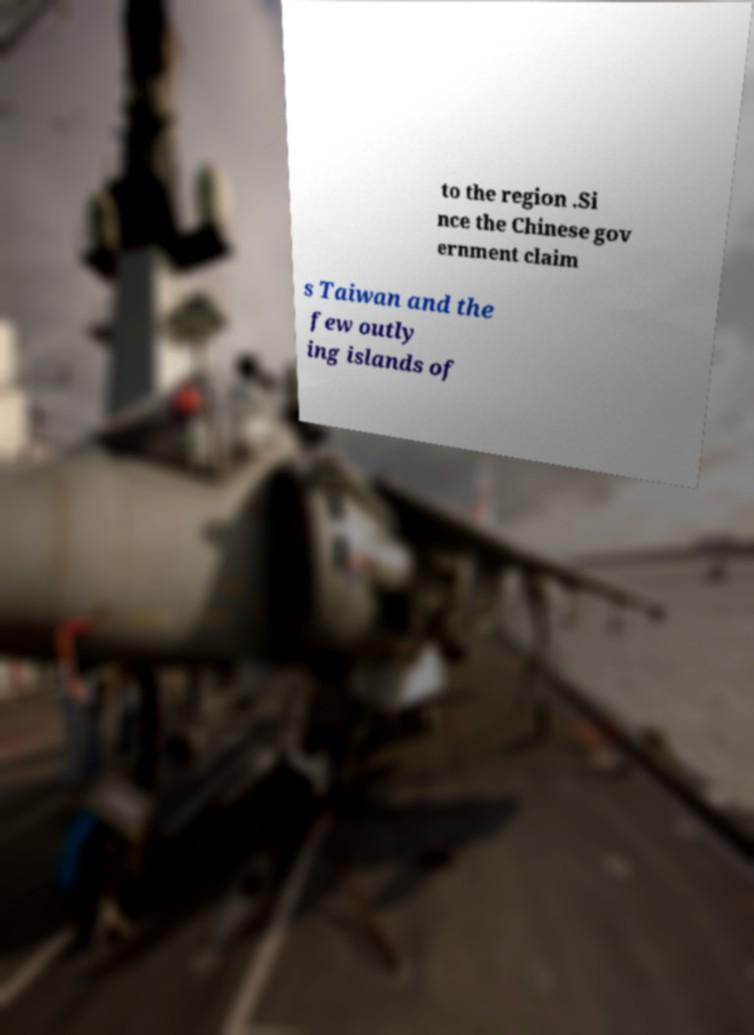There's text embedded in this image that I need extracted. Can you transcribe it verbatim? to the region .Si nce the Chinese gov ernment claim s Taiwan and the few outly ing islands of 